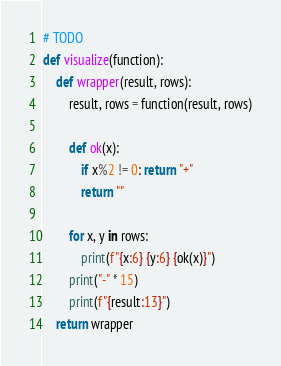Convert code to text. <code><loc_0><loc_0><loc_500><loc_500><_Python_># TODO
def visualize(function):
	def wrapper(result, rows):
		result, rows = function(result, rows)
		
		def ok(x):
			if x%2 != 0: return "+"
			return ""
		
		for x, y in rows:
			print(f"{x:6} {y:6} {ok(x)}")
		print("-" * 15)
		print(f"{result:13}")
	return wrapper</code> 